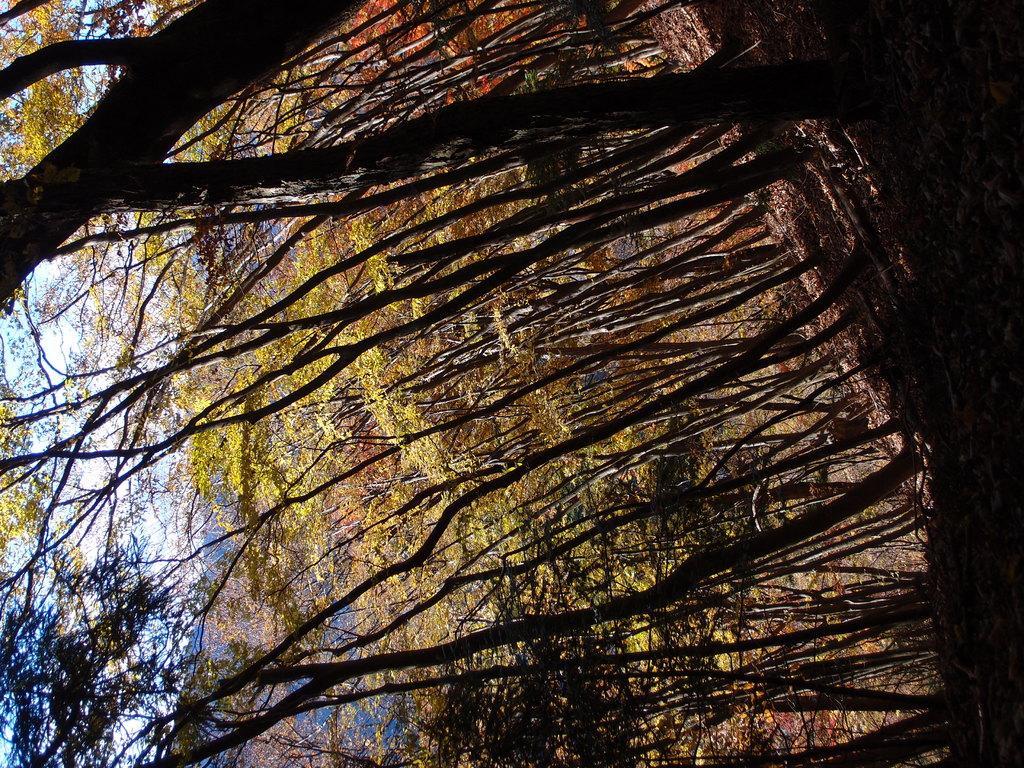Describe this image in one or two sentences. In this picture I can see trees and a blue cloudy sky. 